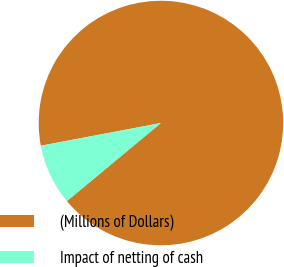<chart> <loc_0><loc_0><loc_500><loc_500><pie_chart><fcel>(Millions of Dollars)<fcel>Impact of netting of cash<nl><fcel>91.95%<fcel>8.05%<nl></chart> 